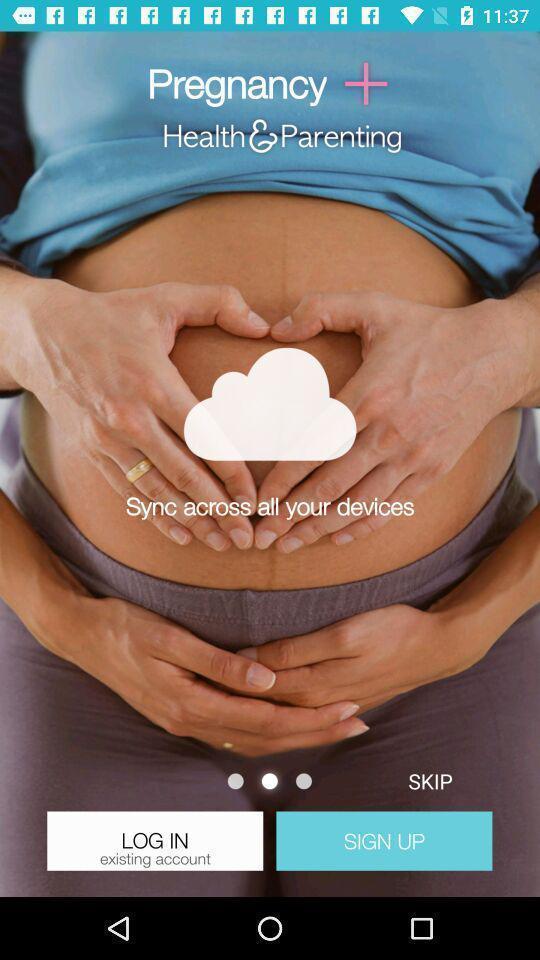Describe the visual elements of this screenshot. Login page of a pregnancy app. 